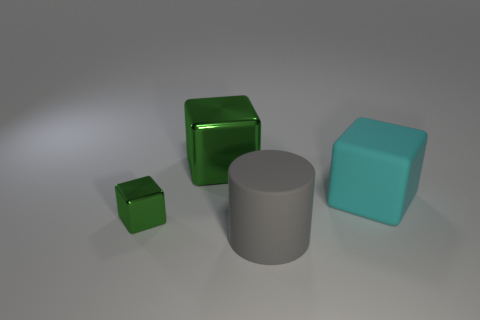What number of green shiny objects have the same size as the rubber cylinder?
Keep it short and to the point. 1. What is the size of the other object that is the same color as the large metallic object?
Ensure brevity in your answer.  Small. How many objects are gray shiny balls or cubes behind the small metal thing?
Make the answer very short. 2. What is the color of the object that is both in front of the matte block and behind the rubber cylinder?
Make the answer very short. Green. Is the size of the gray rubber thing the same as the cyan rubber thing?
Your answer should be very brief. Yes. There is a shiny thing in front of the big cyan cube; what is its color?
Offer a terse response. Green. Are there any metallic things of the same color as the tiny metal cube?
Ensure brevity in your answer.  Yes. What is the color of the metal object that is the same size as the gray matte cylinder?
Keep it short and to the point. Green. Is the big metal thing the same shape as the big cyan thing?
Your answer should be very brief. Yes. What material is the large thing in front of the big cyan rubber thing?
Give a very brief answer. Rubber. 